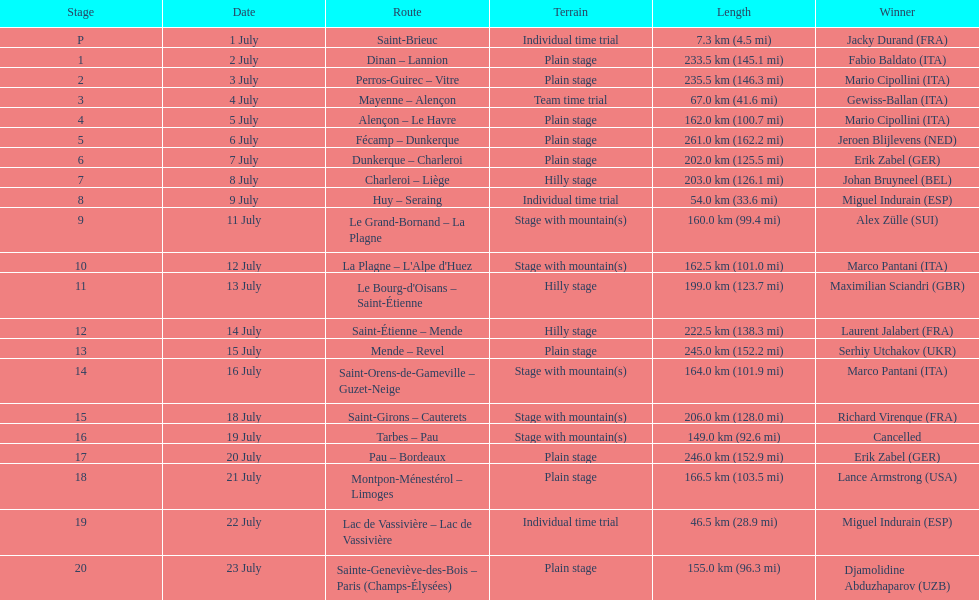Which paths had a minimum distance of 100 km? Dinan - Lannion, Perros-Guirec - Vitre, Alençon - Le Havre, Fécamp - Dunkerque, Dunkerque - Charleroi, Charleroi - Liège, Le Grand-Bornand - La Plagne, La Plagne - L'Alpe d'Huez, Le Bourg-d'Oisans - Saint-Étienne, Saint-Étienne - Mende, Mende - Revel, Saint-Orens-de-Gameville - Guzet-Neige, Saint-Girons - Cauterets, Tarbes - Pau, Pau - Bordeaux, Montpon-Ménestérol - Limoges, Sainte-Geneviève-des-Bois - Paris (Champs-Élysées). 